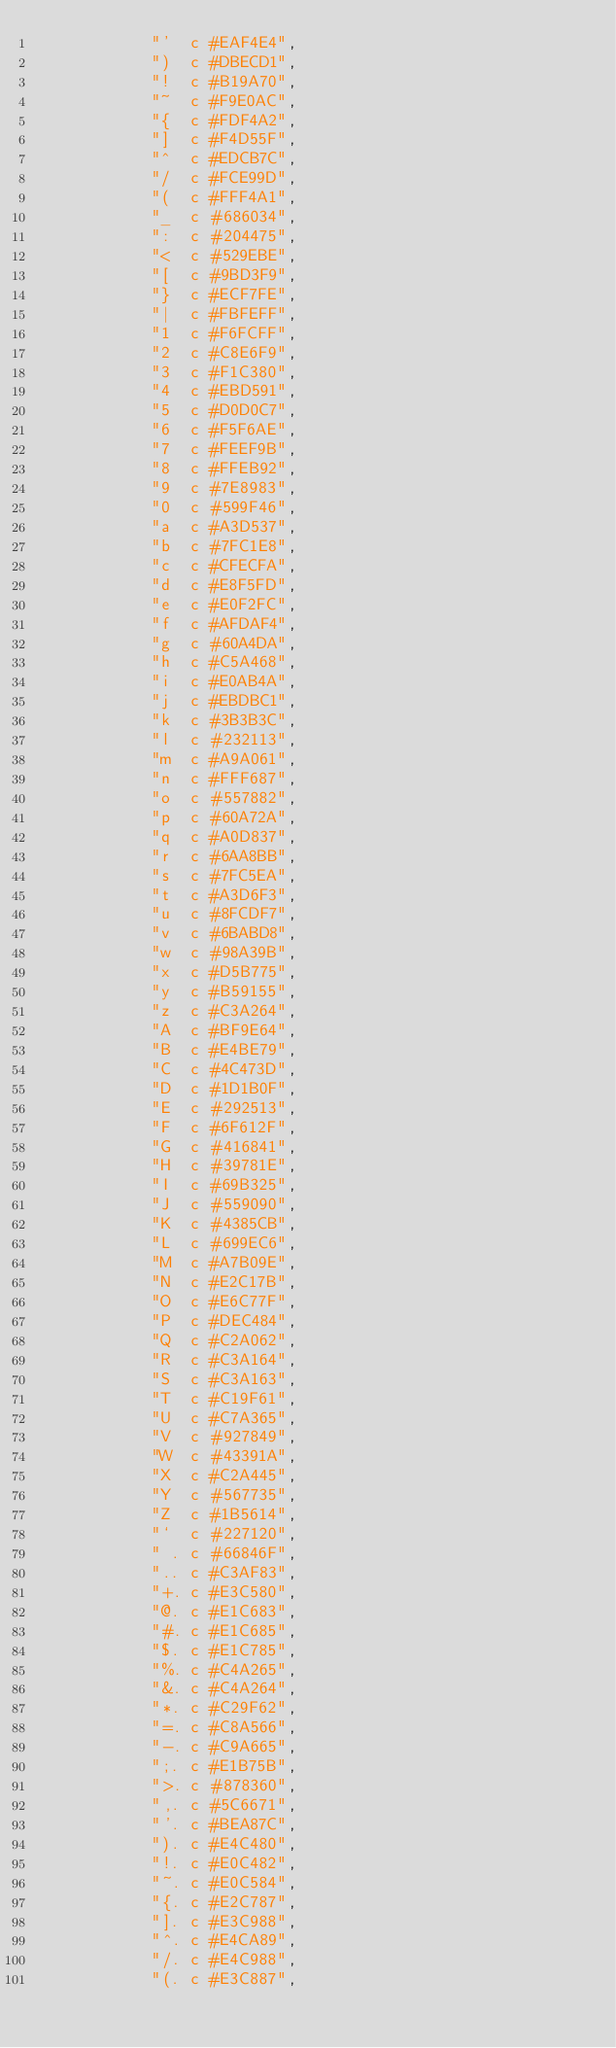<code> <loc_0><loc_0><loc_500><loc_500><_Python_>            "'  c #EAF4E4",
            ")  c #DBECD1",
            "!  c #B19A70",
            "~  c #F9E0AC",
            "{  c #FDF4A2",
            "]  c #F4D55F",
            "^  c #EDCB7C",
            "/  c #FCE99D",
            "(  c #FFF4A1",
            "_  c #686034",
            ":  c #204475",
            "<  c #529EBE",
            "[  c #9BD3F9",
            "}  c #ECF7FE",
            "|  c #FBFEFF",
            "1  c #F6FCFF",
            "2  c #C8E6F9",
            "3  c #F1C380",
            "4  c #EBD591",
            "5  c #D0D0C7",
            "6  c #F5F6AE",
            "7  c #FEEF9B",
            "8  c #FFEB92",
            "9  c #7E8983",
            "0  c #599F46",
            "a  c #A3D537",
            "b  c #7FC1E8",
            "c  c #CFECFA",
            "d  c #E8F5FD",
            "e  c #E0F2FC",
            "f  c #AFDAF4",
            "g  c #60A4DA",
            "h  c #C5A468",
            "i  c #E0AB4A",
            "j  c #EBDBC1",
            "k  c #3B3B3C",
            "l  c #232113",
            "m  c #A9A061",
            "n  c #FFF687",
            "o  c #557882",
            "p  c #60A72A",
            "q  c #A0D837",
            "r  c #6AA8BB",
            "s  c #7FC5EA",
            "t  c #A3D6F3",
            "u  c #8FCDF7",
            "v  c #6BABD8",
            "w  c #98A39B",
            "x  c #D5B775",
            "y  c #B59155",
            "z  c #C3A264",
            "A  c #BF9E64",
            "B  c #E4BE79",
            "C  c #4C473D",
            "D  c #1D1B0F",
            "E  c #292513",
            "F  c #6F612F",
            "G  c #416841",
            "H  c #39781E",
            "I  c #69B325",
            "J  c #559090",
            "K  c #4385CB",
            "L  c #699EC6",
            "M  c #A7B09E",
            "N  c #E2C17B",
            "O  c #E6C77F",
            "P  c #DEC484",
            "Q  c #C2A062",
            "R  c #C3A164",
            "S  c #C3A163",
            "T  c #C19F61",
            "U  c #C7A365",
            "V  c #927849",
            "W  c #43391A",
            "X  c #C2A445",
            "Y  c #567735",
            "Z  c #1B5614",
            "`  c #227120",
            " . c #66846F",
            ".. c #C3AF83",
            "+. c #E3C580",
            "@. c #E1C683",
            "#. c #E1C685",
            "$. c #E1C785",
            "%. c #C4A265",
            "&. c #C4A264",
            "*. c #C29F62",
            "=. c #C8A566",
            "-. c #C9A665",
            ";. c #E1B75B",
            ">. c #878360",
            ",. c #5C6671",
            "'. c #BEA87C",
            "). c #E4C480",
            "!. c #E0C482",
            "~. c #E0C584",
            "{. c #E2C787",
            "]. c #E3C988",
            "^. c #E4CA89",
            "/. c #E4C988",
            "(. c #E3C887",</code> 